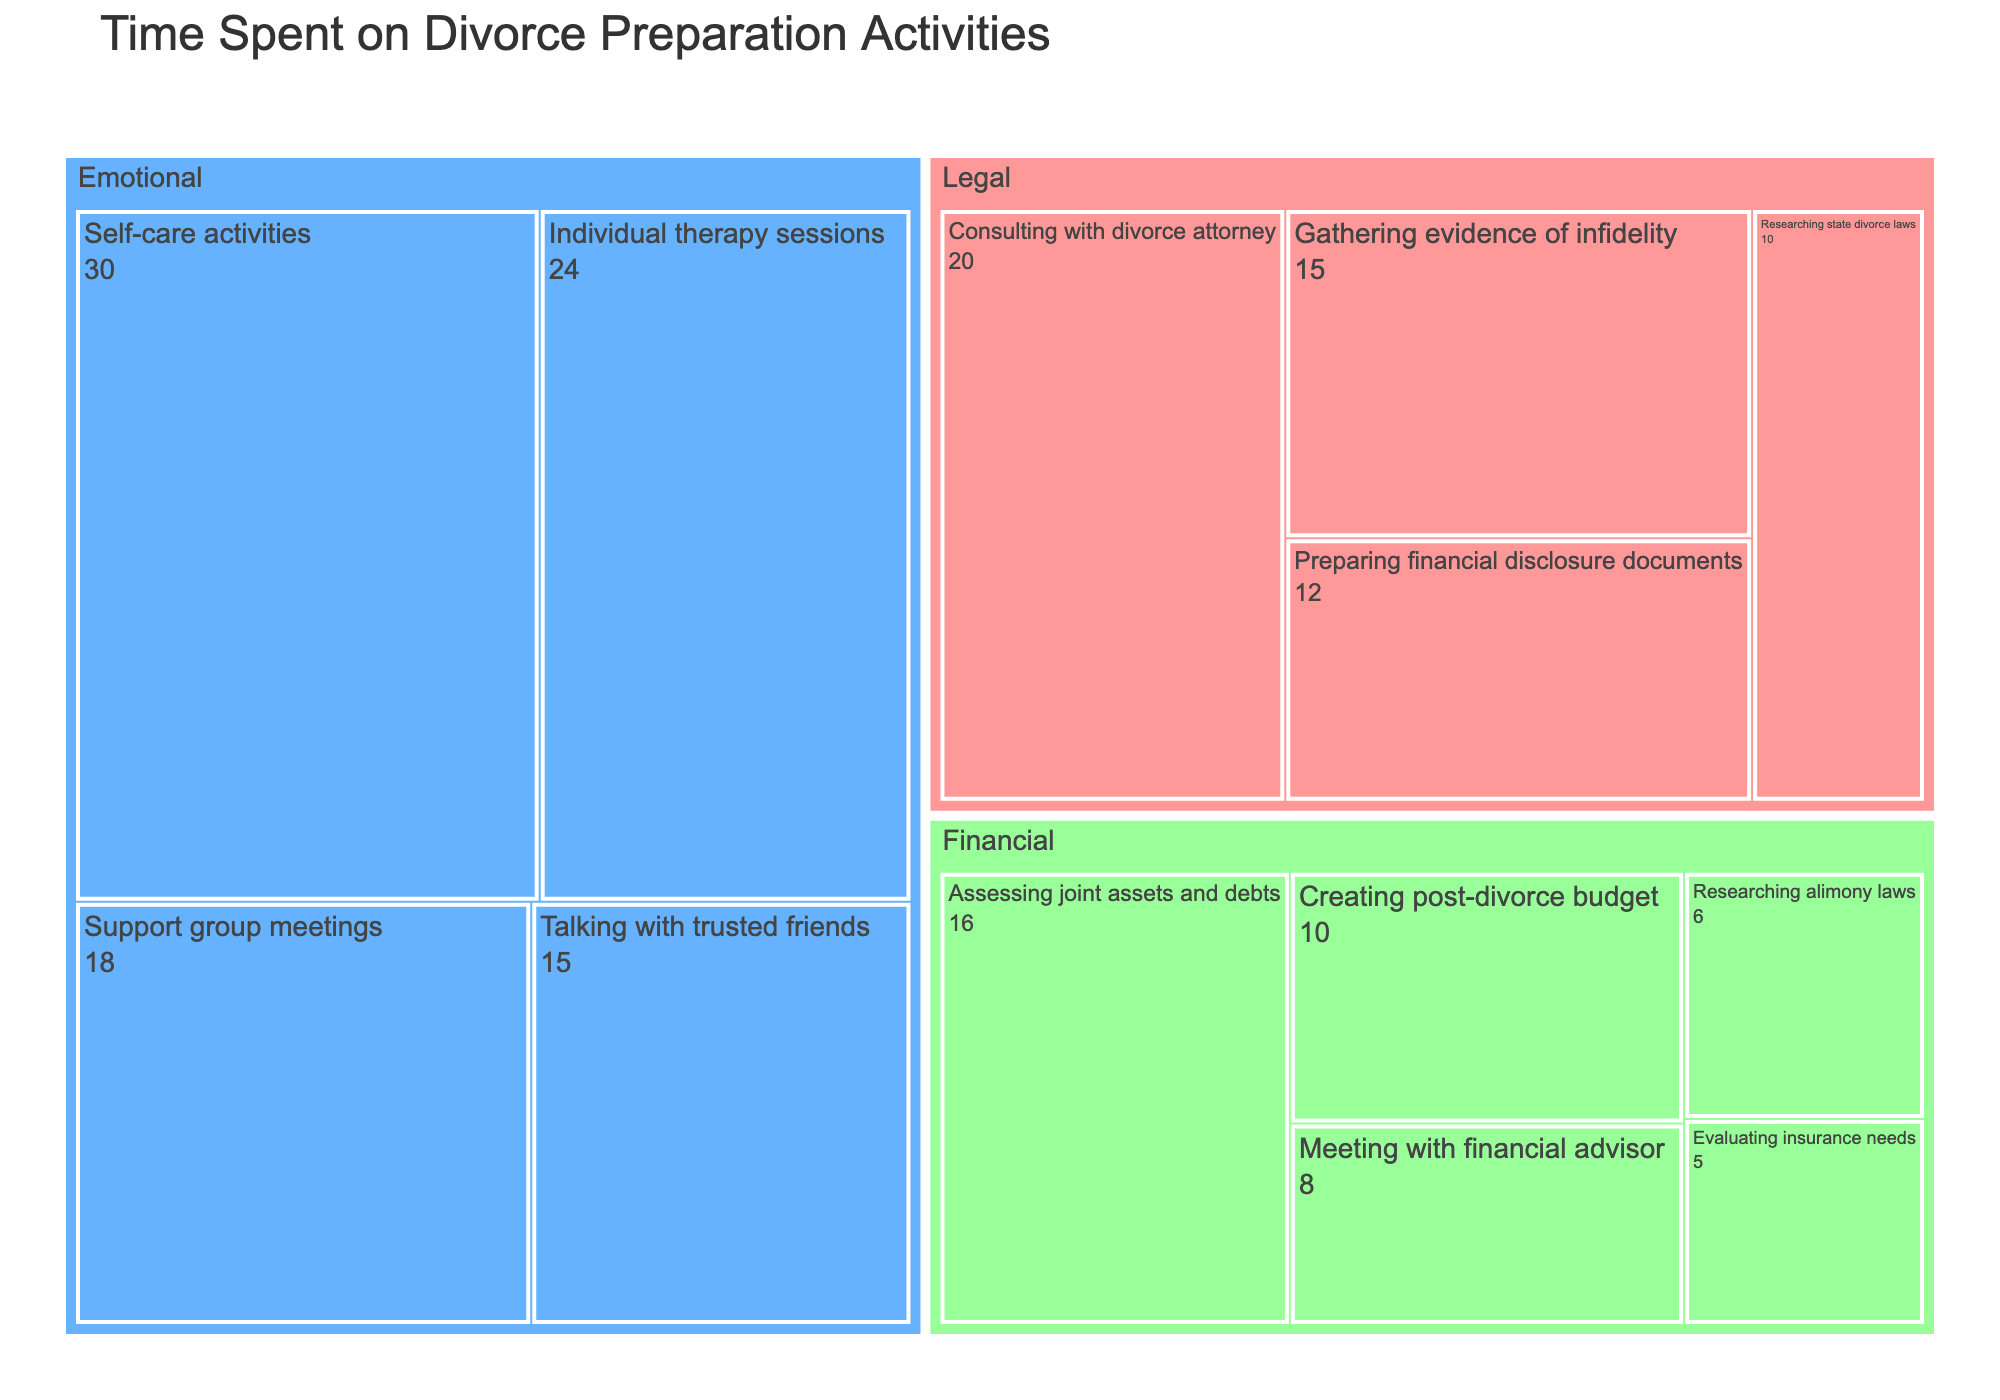What's the title of the treemap? The title of the treemap is usually located at the top of the figure. It provides a quick summary of what the figure represents.
Answer: Time Spent on Divorce Preparation Activities How many hours are spent on financial activities in total? Add up the hours for each financial subcategory: 8 (Meeting with financial advisor) + 16 (Assessing joint assets and debts) + 10 (Creating post-divorce budget) + 6 (Researching alimony laws) + 5 (Evaluating insurance needs). This sums up to 45 hours.
Answer: 45 Which subcategory under Emotional activities has the highest number of hours spent? Look at the values for each subcategory under Emotional activities and identify the highest number: Individual therapy sessions (24), Support group meetings (18), Self-care activities (30), Talking with trusted friends (15). The highest value is 30 for Self-care activities.
Answer: Self-care activities Is more time spent on Emotional or Legal activities? Add up the hours for each subcategory under Emotional and Legal categories. Emotional: 24 + 18 + 30 + 15 = 87 hours. Legal: 20 + 15 + 10 + 12 = 57 hours. Comparatively, more time is spent on Emotional activities.
Answer: Emotional What is the difference in time spent between Individual therapy sessions and Consulting with a divorce attorney? Subtract the hours spent on "Consulting with divorce attorney" from "Individual therapy sessions": 24 (Individual therapy sessions) - 20 (Consulting with divorce attorney) = 4 hours.
Answer: 4 hours Identify the least time-consuming activity under Legal activities. Look at the values for each subcategory under Legal activities and identify the smallest number: Consulting with divorce attorney (20), Gathering evidence of infidelity (15), Researching state divorce laws (10), Preparing financial disclosure documents (12). The least value is 10 for Researching state divorce laws.
Answer: Researching state divorce laws How many subcategories are there in total for all categories combined? Count the number of subcategories listed under each category: 4 (Legal) + 4 (Emotional) + 5 (Financial) = 13 subcategories in total.
Answer: 13 Which category has the highest total number of hours spent and what is that total? To find the category with the highest total, sum the hours for each category: 
Legal = 20 + 15 + 10 + 12 = 57 hours,
Emotional = 24 + 18 + 30 + 15 = 87 hours,
Financial = 8 + 16 + 10 + 6 + 5 = 45 hours.
The highest total is 87 hours for Emotional activities.
Answer: Emotional, 87 hours What percentage of the total time spent on divorce preparation activities is dedicated to Researching state divorce laws? First, find the total time spent on all activities by summing all the hours: 220 hours. Then calculate the percentage of time spent on "Researching state divorce laws": (10 / 220) * 100 ≈ 4.545%.
Answer: ≈ 4.545% 